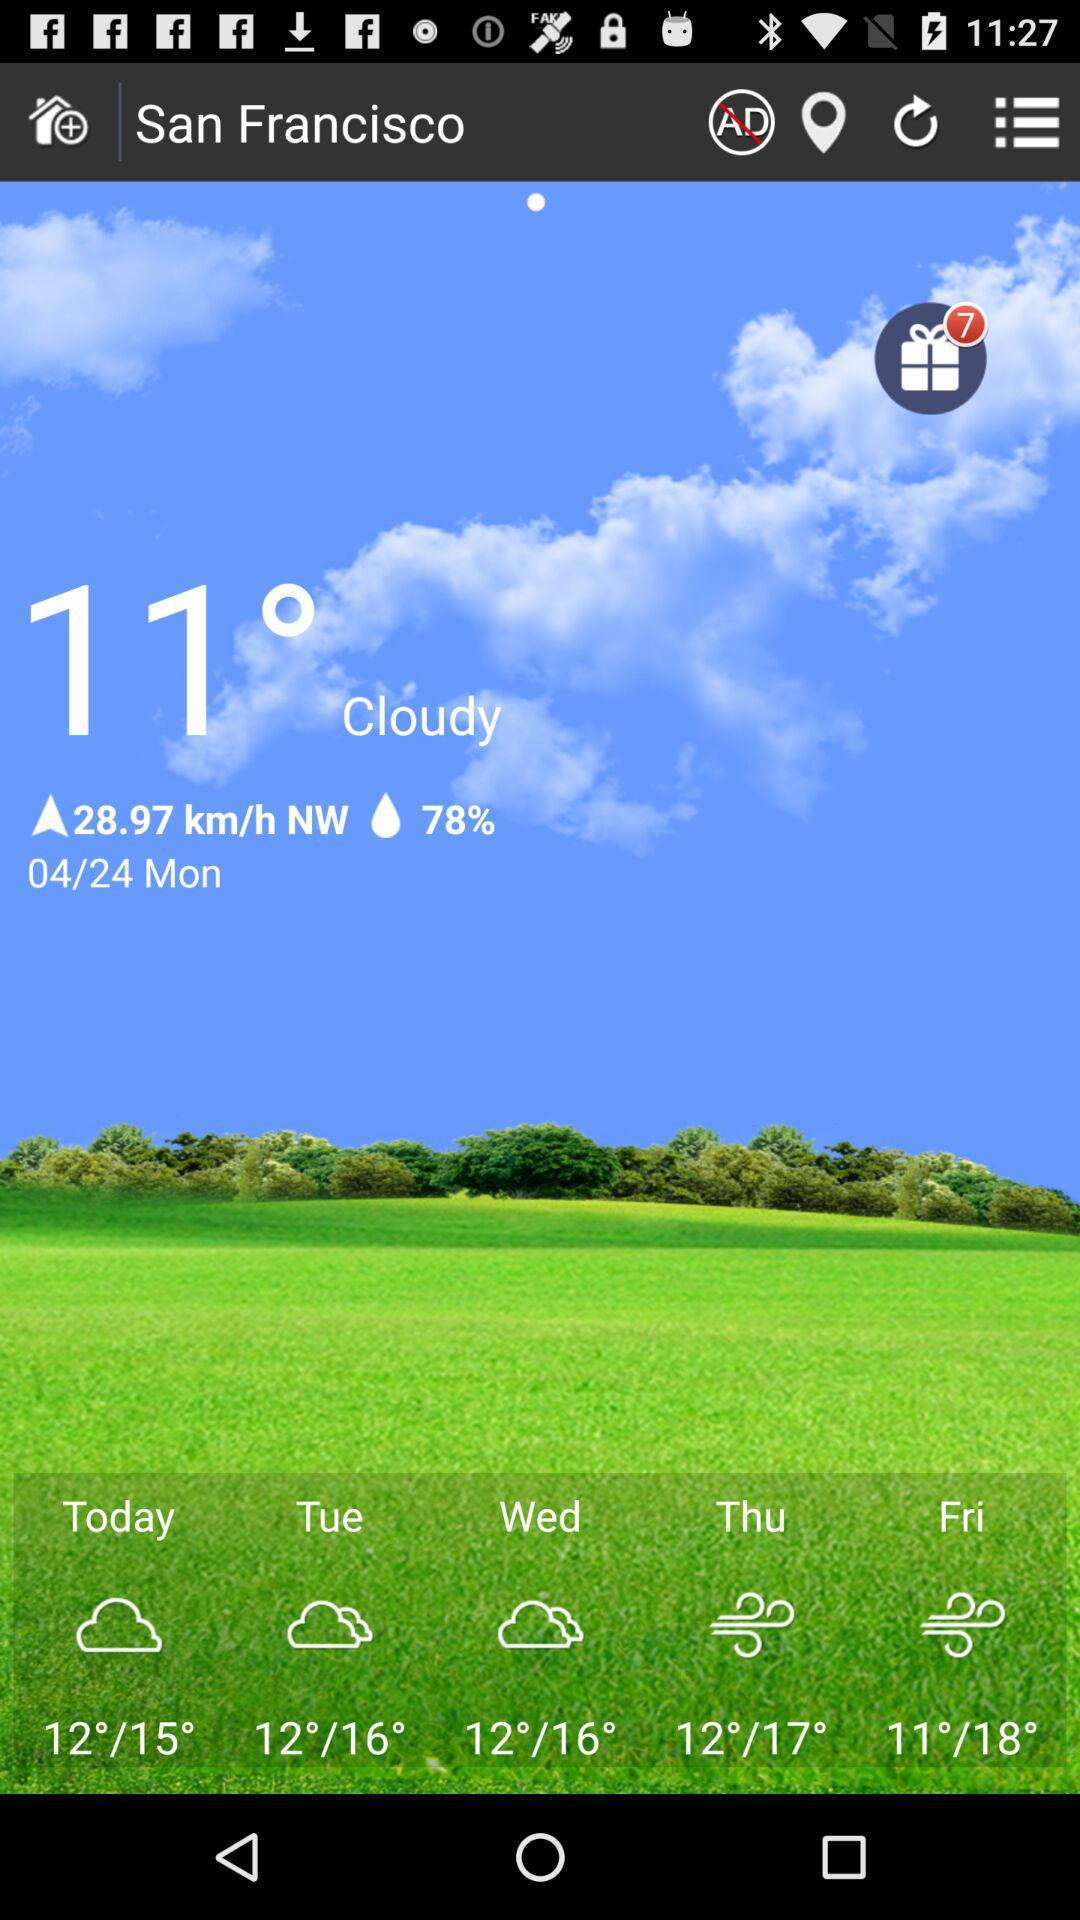What is the temperature shown on the screen? The temperature is 11°. 